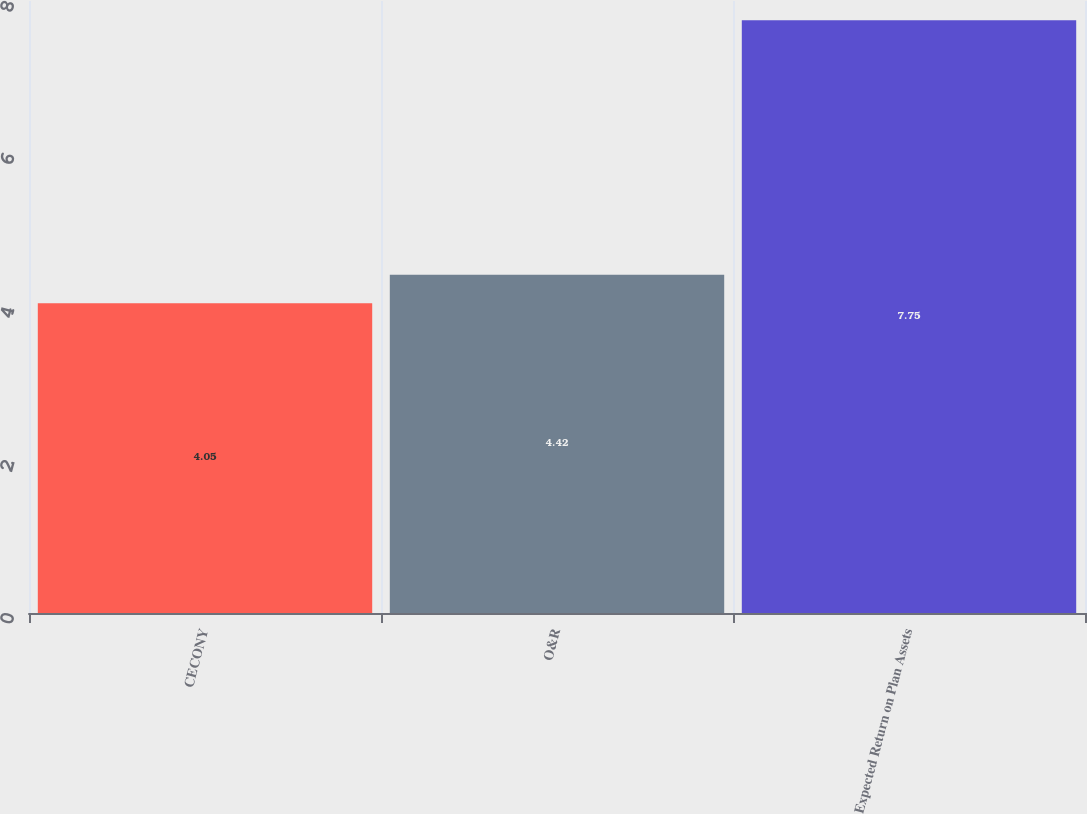<chart> <loc_0><loc_0><loc_500><loc_500><bar_chart><fcel>CECONY<fcel>O&R<fcel>Expected Return on Plan Assets<nl><fcel>4.05<fcel>4.42<fcel>7.75<nl></chart> 